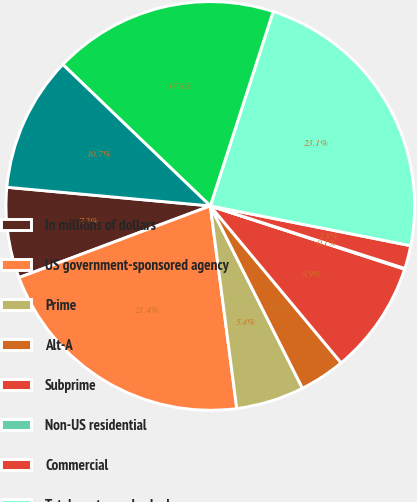Convert chart to OTSL. <chart><loc_0><loc_0><loc_500><loc_500><pie_chart><fcel>In millions of dollars<fcel>US government-sponsored agency<fcel>Prime<fcel>Alt-A<fcel>Subprime<fcel>Non-US residential<fcel>Commercial<fcel>Total mortgage-backed<fcel>US Treasury<fcel>Agency obligations<nl><fcel>7.16%<fcel>21.36%<fcel>5.38%<fcel>3.61%<fcel>8.93%<fcel>0.06%<fcel>1.83%<fcel>23.14%<fcel>17.81%<fcel>10.71%<nl></chart> 